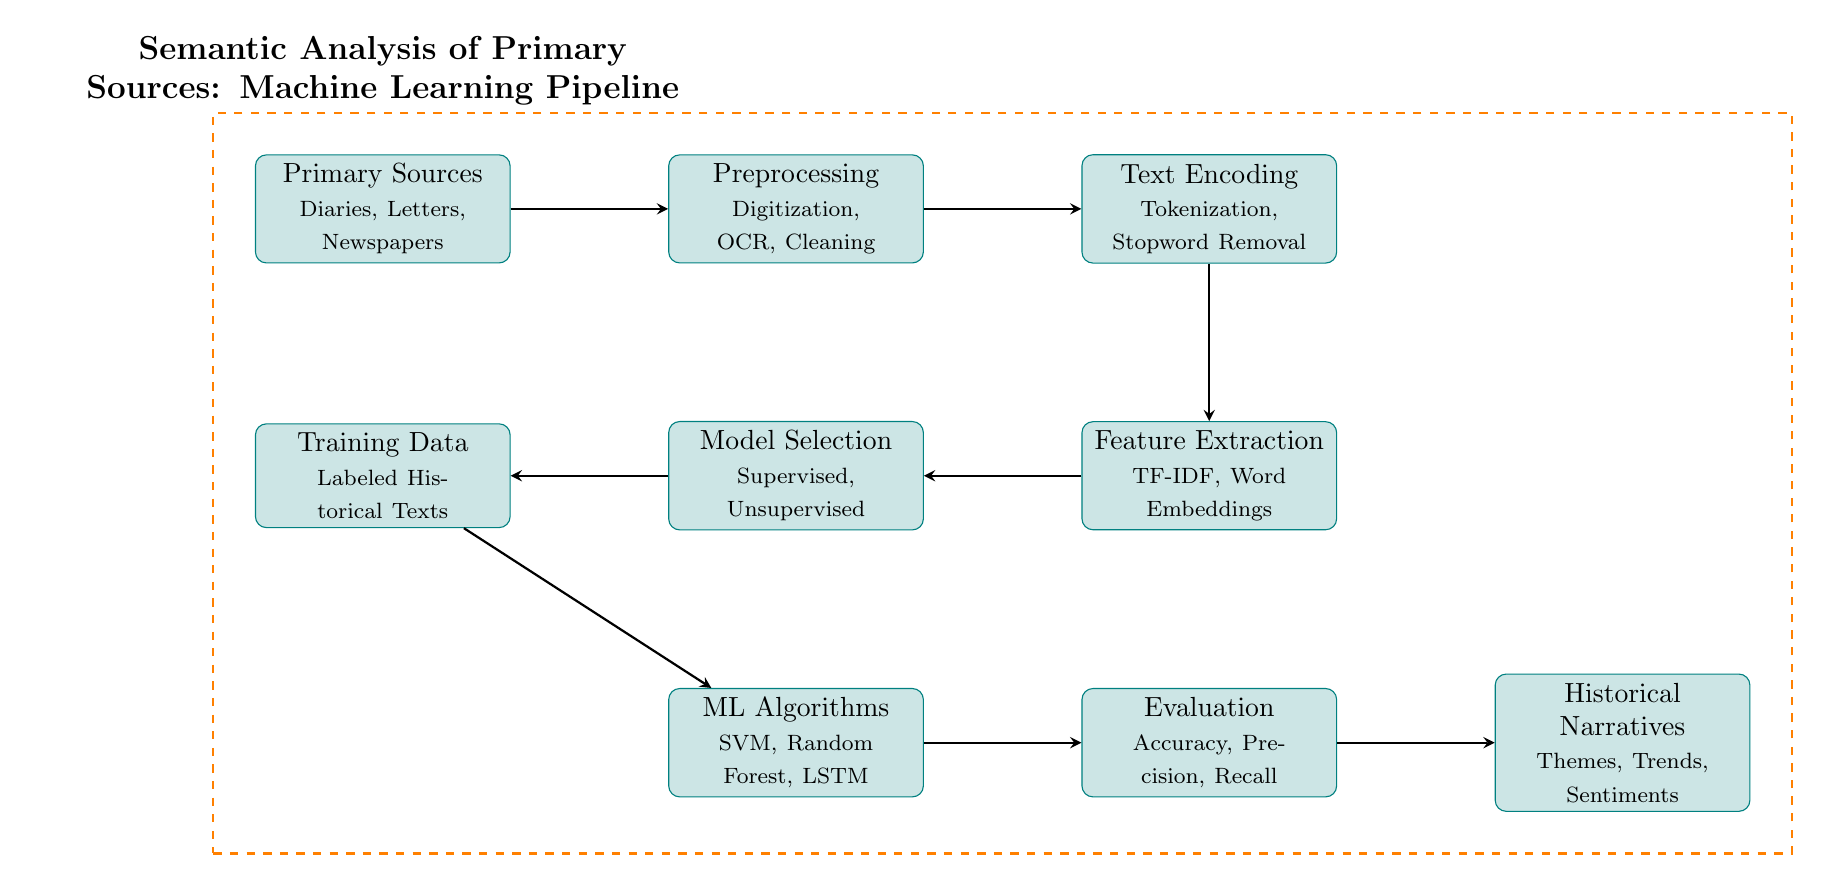What are examples of primary sources in this context? The diagram lists diaries, letters, and newspapers as examples of primary sources, which are essential materials for historical analysis.
Answer: Diaries, Letters, Newspapers What is the first step in the machine learning pipeline? The first node in the diagram, labeled "Primary Sources", indicates that input data consists of primary sources such as diaries and letters.
Answer: Primary Sources How many nodes are there in the machine learning pipeline? By counting each labeled process in the diagram, one can determine that there are nine distinct nodes, which represent various stages in the analysis.
Answer: 9 What processing step follows Text Encoding? The arrow leading from the "Text Encoding" node to the next node indicates that "Feature Extraction" follows immediately after the text encoding process.
Answer: Feature Extraction Which machine learning algorithms are mentioned in the diagram? The diagram outlines three specific algorithms located in the "ML Algorithms" node: SVM, Random Forest, and LSTM, utilized in the learning process.
Answer: SVM, Random Forest, LSTM How does the pipeline transition from Training Data to Evaluation? The connection from "Training Data" to "ML Algorithms" represents that historical texts are used to train machine learning algorithms, which are then evaluated through metrics for their effectiveness.
Answer: Training Data to ML Algorithms What is the final output of the machine learning pipeline? The output is described in the last node labeled "Historical Narratives" that aggregates the themes, trends, and sentiments derived from the processed data.
Answer: Historical Narratives What type of analysis is being conducted on primary sources? The title and the context provided indicate that the type of analysis is semantic, focusing on understanding narratives within primary historical texts.
Answer: Semantic Analysis What step entails cleaning the data? The "Preprocessing" node specifies that actions like digitization, OCR (optical character recognition), and cleaning occur to prepare the data for further analysis.
Answer: Preprocessing 